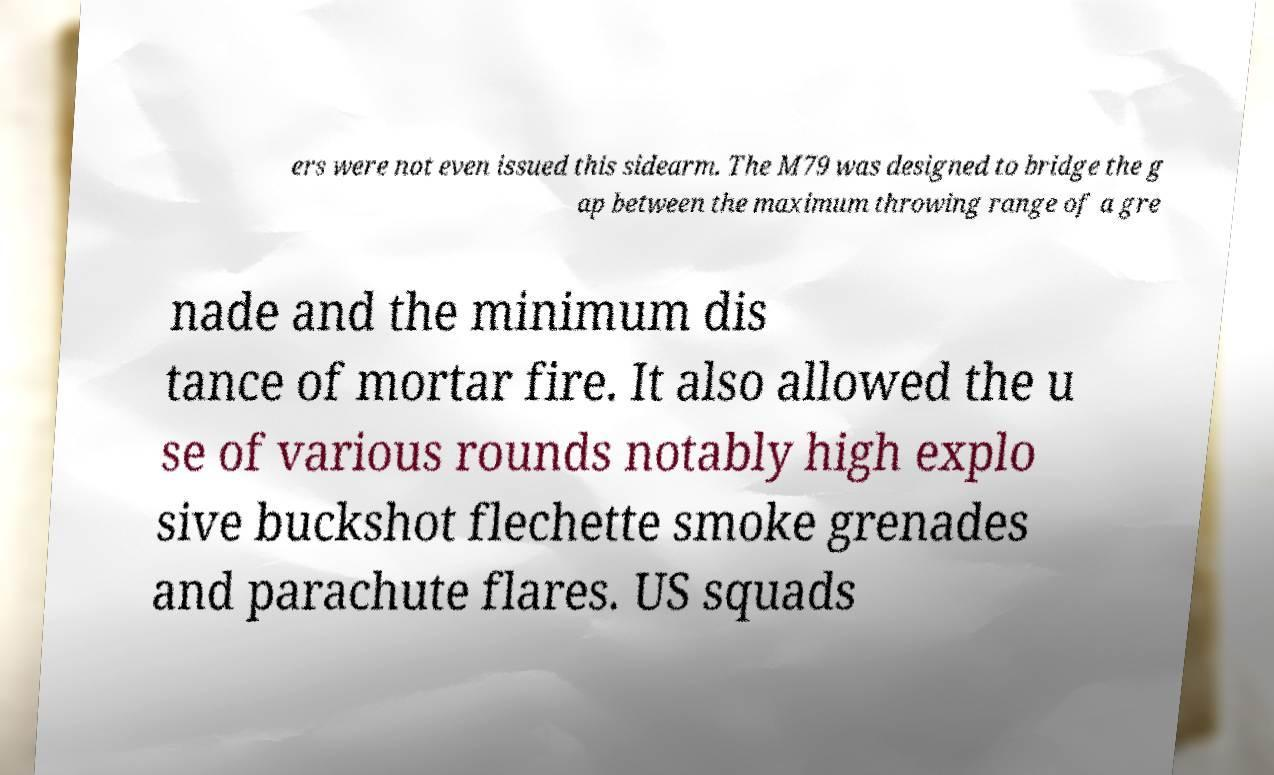Please read and relay the text visible in this image. What does it say? ers were not even issued this sidearm. The M79 was designed to bridge the g ap between the maximum throwing range of a gre nade and the minimum dis tance of mortar fire. It also allowed the u se of various rounds notably high explo sive buckshot flechette smoke grenades and parachute flares. US squads 